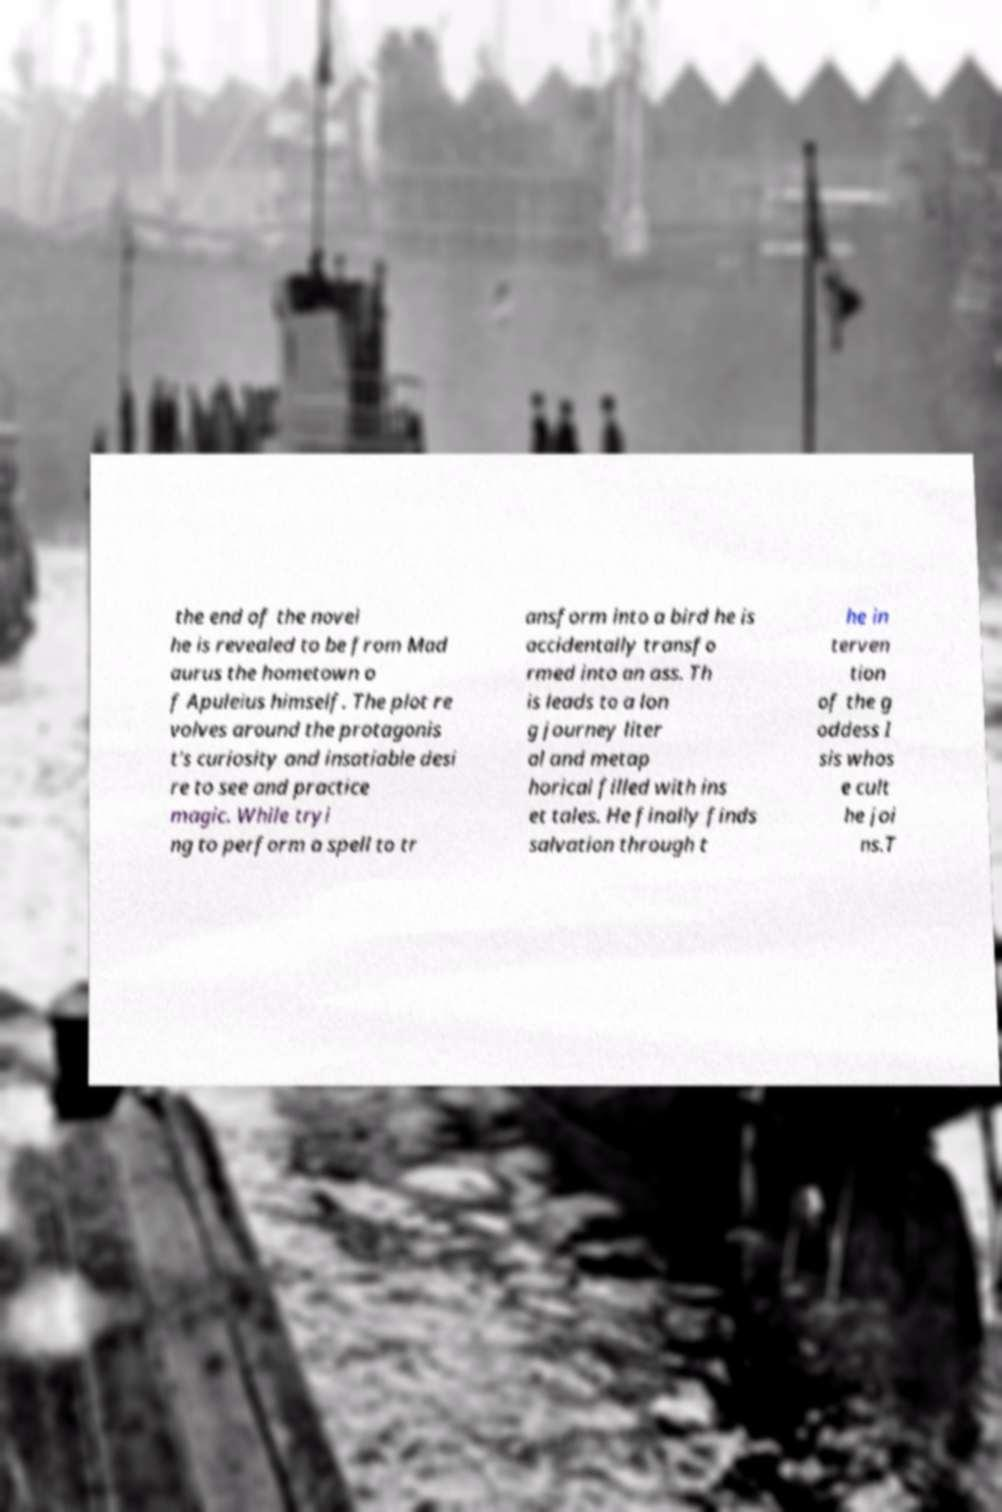What messages or text are displayed in this image? I need them in a readable, typed format. the end of the novel he is revealed to be from Mad aurus the hometown o f Apuleius himself. The plot re volves around the protagonis t's curiosity and insatiable desi re to see and practice magic. While tryi ng to perform a spell to tr ansform into a bird he is accidentally transfo rmed into an ass. Th is leads to a lon g journey liter al and metap horical filled with ins et tales. He finally finds salvation through t he in terven tion of the g oddess I sis whos e cult he joi ns.T 